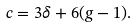Convert formula to latex. <formula><loc_0><loc_0><loc_500><loc_500>c = 3 \delta + 6 ( g - 1 ) .</formula> 